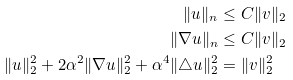<formula> <loc_0><loc_0><loc_500><loc_500>\| u \| _ { n } & \leq C \| v \| _ { 2 } \\ \| \nabla u \| _ { n } & \leq C \| v \| _ { 2 } \\ \| u \| _ { 2 } ^ { 2 } + 2 \alpha ^ { 2 } \| \nabla u \| _ { 2 } ^ { 2 } + \alpha ^ { 4 } \| \triangle u \| _ { 2 } ^ { 2 } & = \| v \| _ { 2 } ^ { 2 }</formula> 